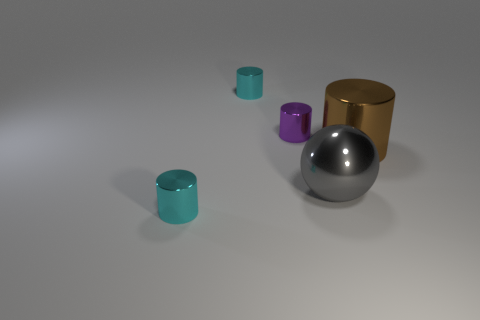What could these objects represent in an abstract piece of art? In an abstract artistic interpretation, these objects could represent the diversity of elements in a system working together. The sphere could symbolize wholeness or unity, the golden cylinder might stand for stability and wealth, while the smaller cylinders suggest variety and individuality. The varying heights and positions could indicate a sense of balance or hierarchy within the group. 